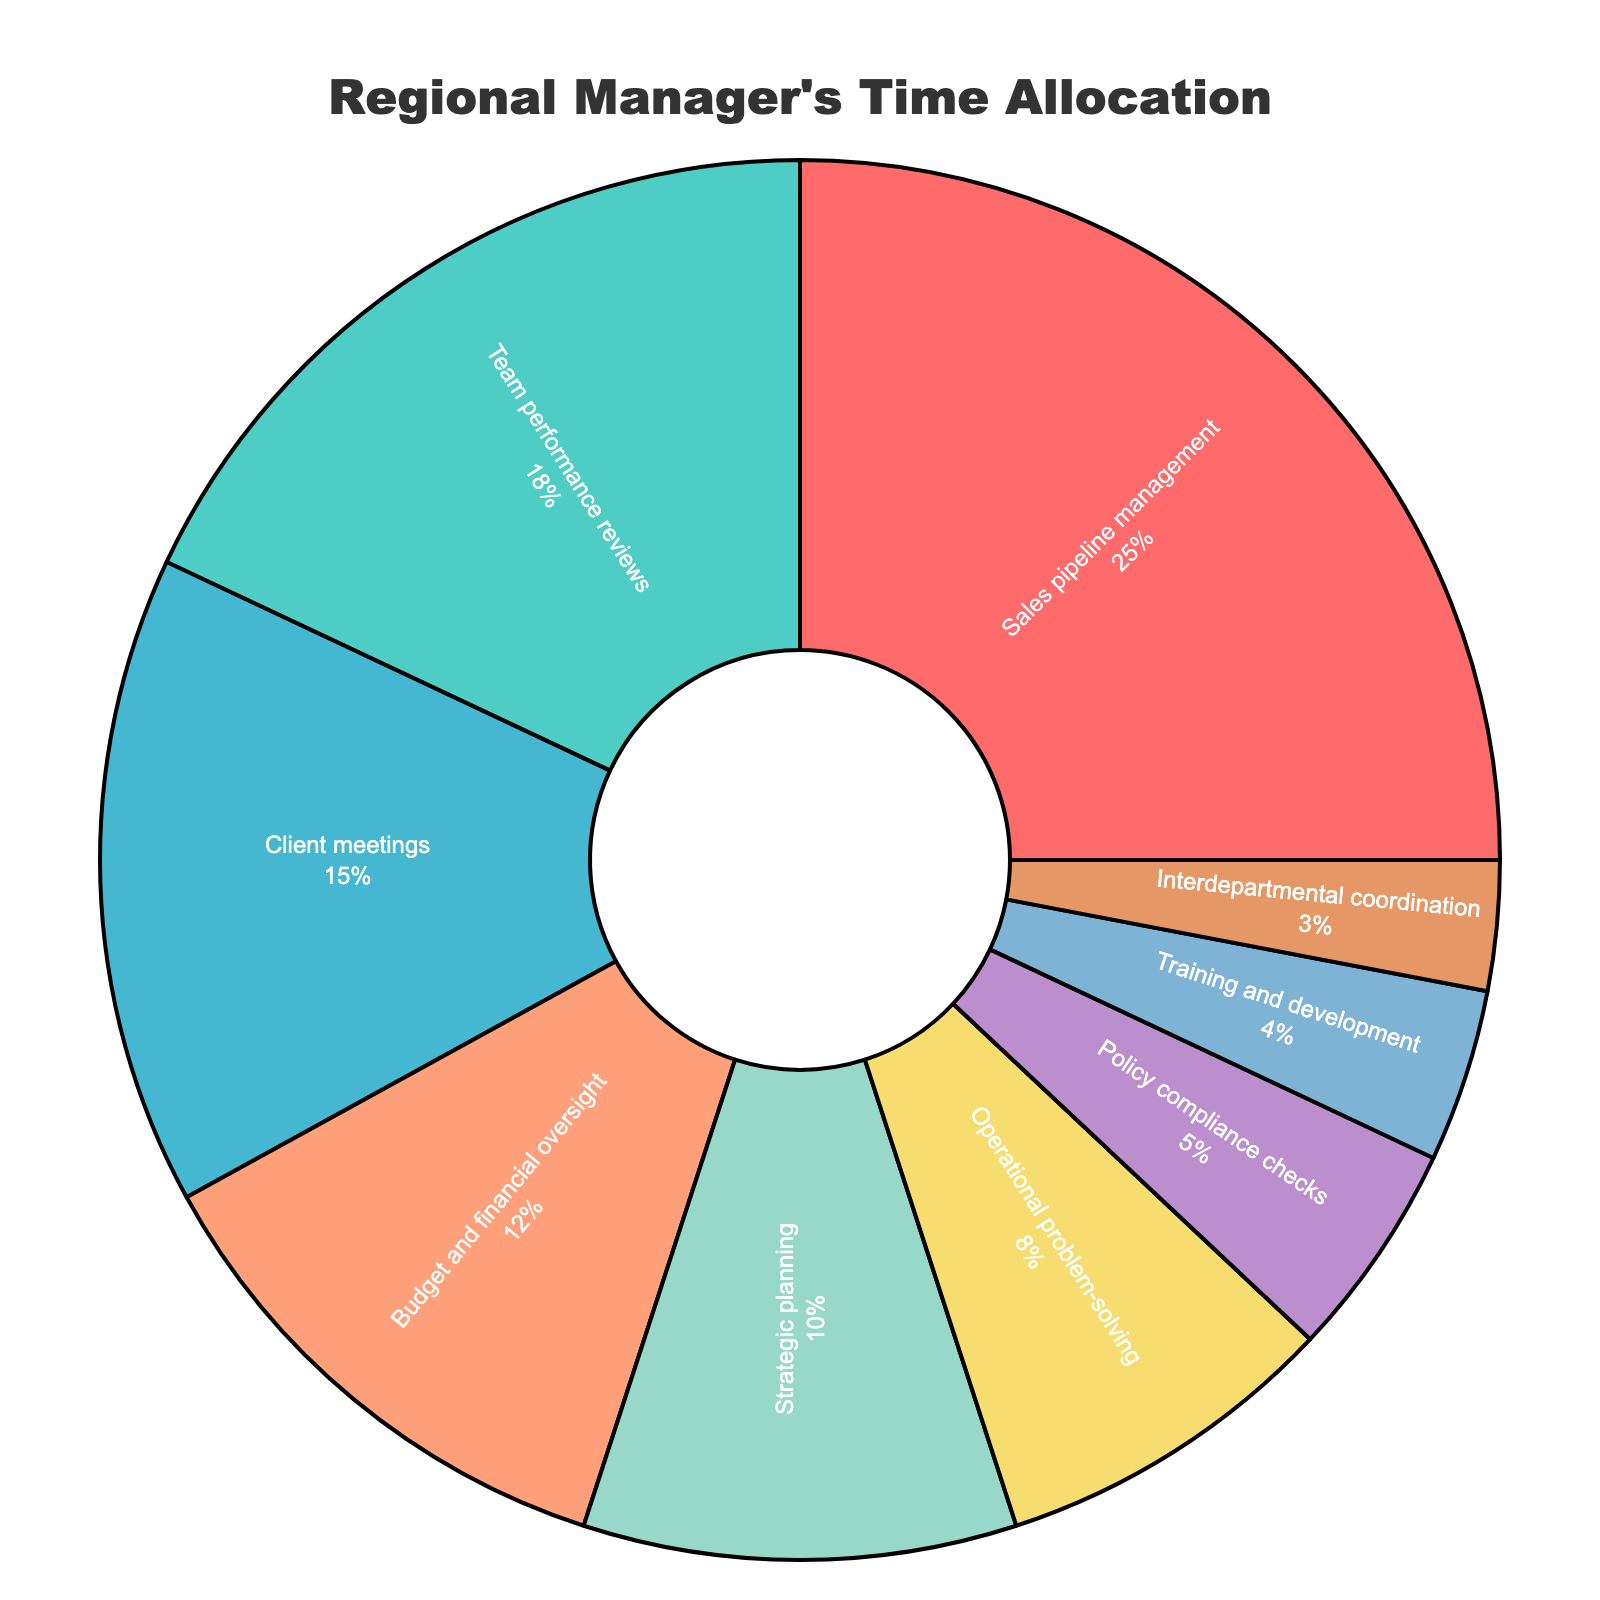Which activity takes up the most time in the regional manager's schedule? The pie chart shows various activities with their corresponding percentages. The activity with the largest slice is "Sales pipeline management" which occupies 25% of the total time.
Answer: Sales pipeline management What is the total percentage of time allocated to client meetings and team performance reviews? By summing the percentages of "Client meetings" (15%) and "Team performance reviews" (18%), the total is 15% + 18% = 33%.
Answer: 33% Between operational problem-solving and policy compliance checks, which activity has a higher percentage of time allocation, and by how much? "Operational problem-solving" has 8%, while "Policy compliance checks" has 5%. The difference is 8% - 5% = 3%.
Answer: Operational problem-solving by 3% How does the time spent on strategic planning compare to that on budget and financial oversight? The percentage for "Strategic planning" is 10%, while for "Budget and financial oversight" it is 12%. Therefore, budget and financial oversight has 2% more time allocated.
Answer: Budget and financial oversight is 2% more What percentage of time is spent on activities related to coordination, including interdepartmental coordination and operational problem-solving? Sum the percentages of "Interdepartmental coordination" (3%) and "Operational problem-solving" (8%). The total is 3% + 8% = 11%.
Answer: 11% What fraction of the regional manager's time is dedicated to activities other than sales pipeline management, team performance reviews, and client meetings? Subtract the combined percentage of "Sales pipeline management" (25%), "Team performance reviews" (18%), and "Client meetings" (15%) from 100%. The total is 100% - (25% + 18% + 15%) = 100% - 58% = 42%.
Answer: 42% Is more time spent on training and development or interdepartmental coordination? Compare the percentages. "Training and development" has 4% and "Interdepartmental coordination" has 3%. More time is spent on training and development.
Answer: Training and development Which activity occupies the smallest portion of the regional manager's time? The smallest segment of the pie chart belongs to "Interdepartmental coordination," which has 3% of the time allocation.
Answer: Interdepartmental coordination Calculate the total percentage of time spent on budget and financial oversight and operational problem-solving. Add the percentages of "Budget and financial oversight" (12%) and "Operational problem-solving" (8%). The total is 12% + 8% = 20%.
Answer: 20% 